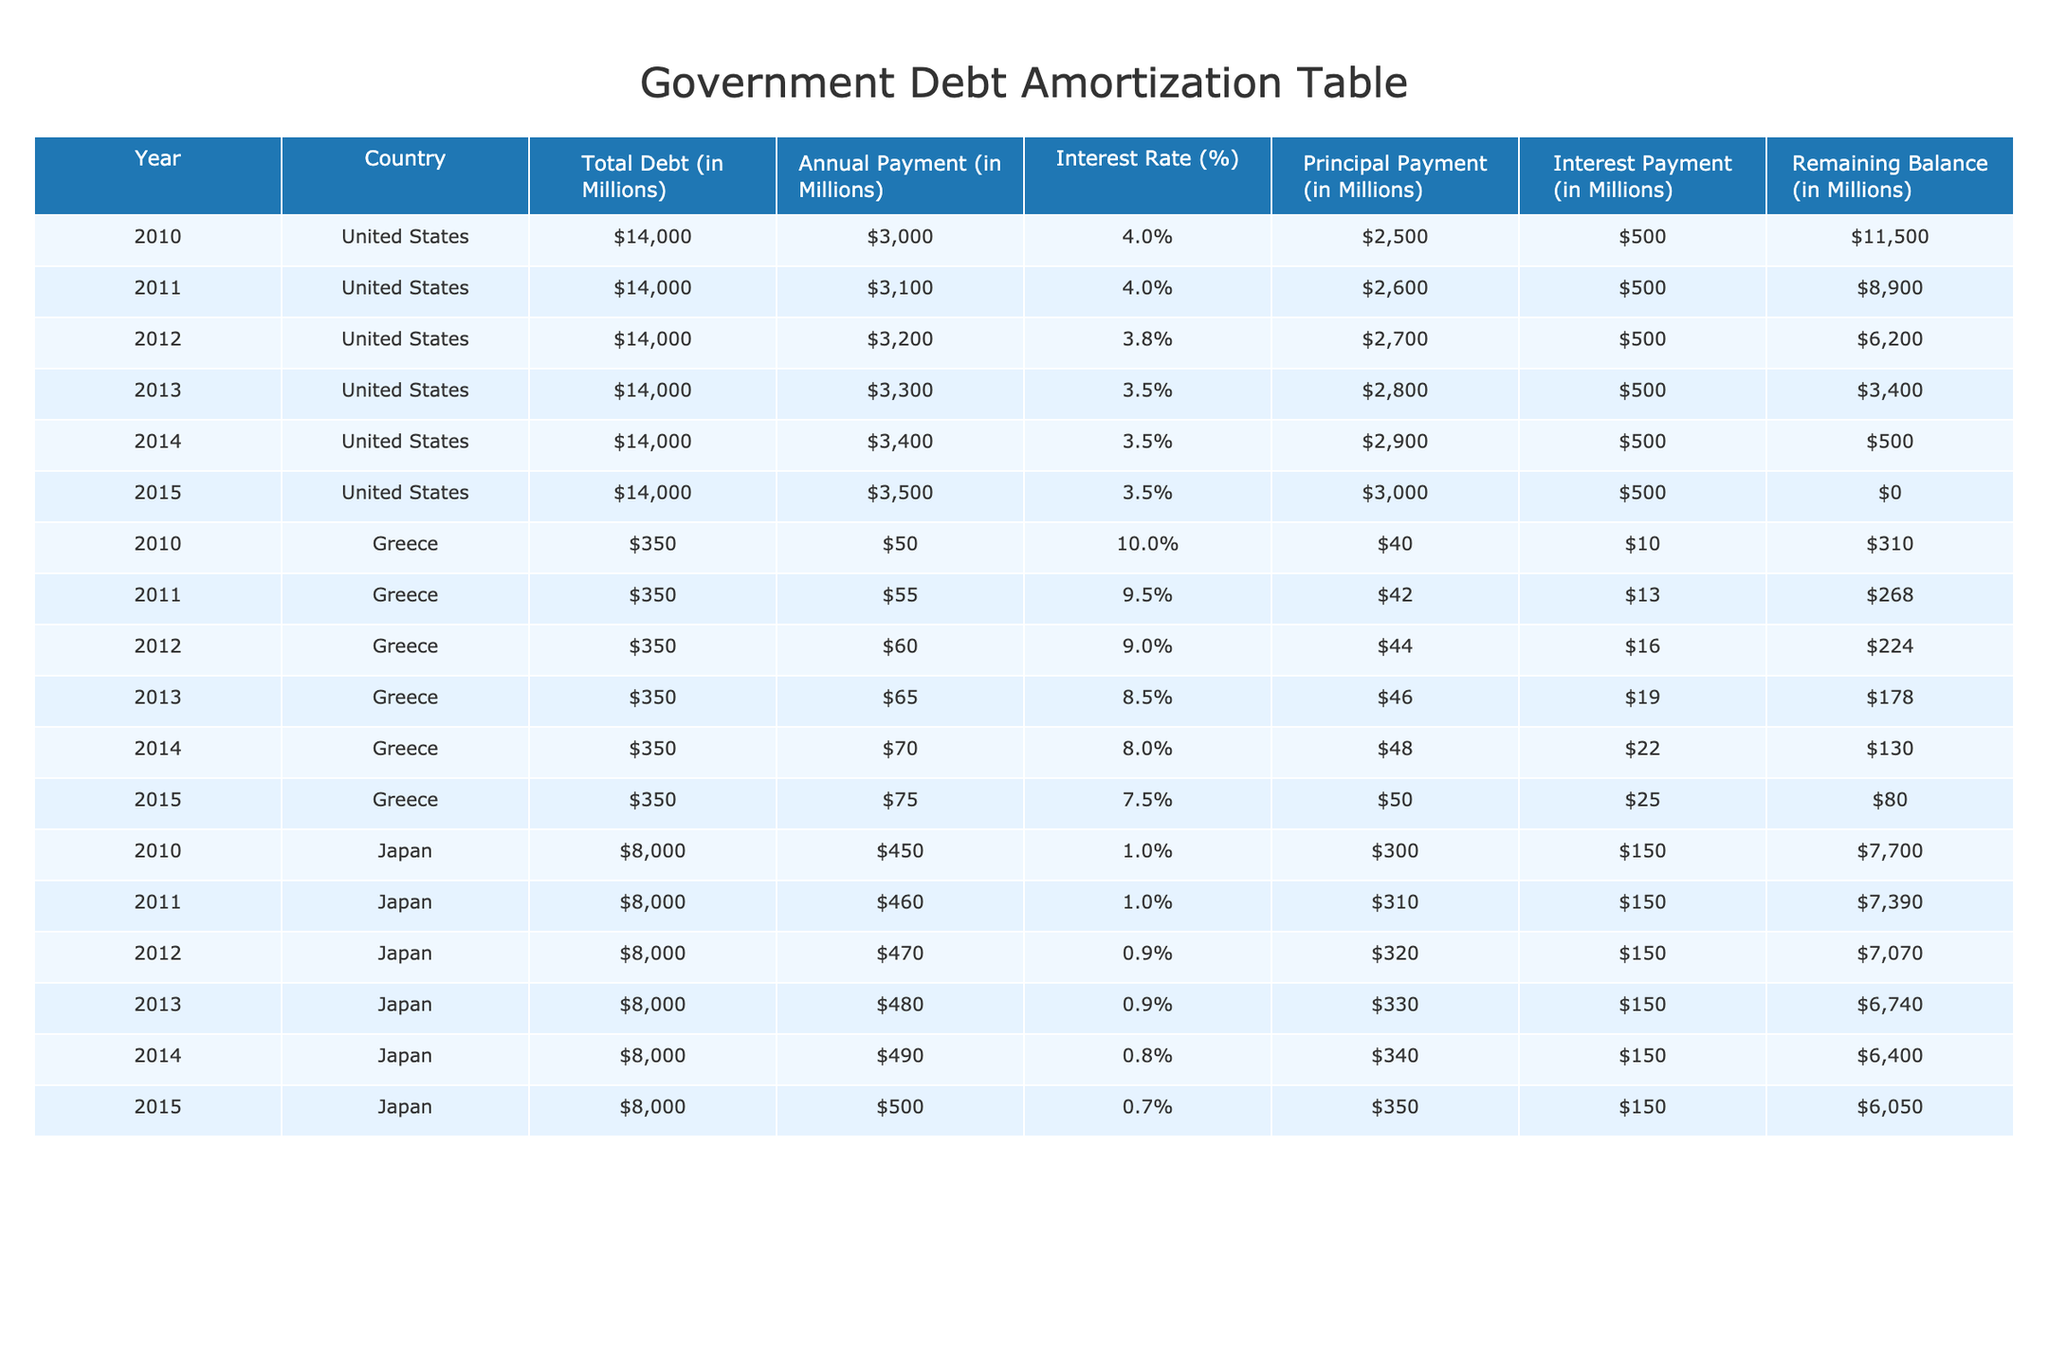What was the annual payment made by the United States in 2015? From the row corresponding to the United States in the year 2015, the annual payment listed is $3,500 million.
Answer: $3,500 million What is the remaining balance of Greece's debt in 2013? The table shows that, for Greece in 2013, the remaining balance is $178 million.
Answer: $178 million What was the total principal payment made by the United States from 2010 to 2015? Adding the principal payments for each year: $2,500 + $2,600 + $2,700 + $2,800 + $2,900 + $3,000 = $15,500 million.
Answer: $15,500 million Is the interest rate for Japan's debt higher than that of Greece in 2010? In 2010, Japan has an interest rate of 1.0%, whereas Greece has an interest rate of 10.0%. Since 1.0% is not higher than 10.0%, the answer is no.
Answer: No What percentage of the total debt did Greece pay off by 2015 compared to its total debt in 2010? Greece's total debt in 2010 was $350 million, and by 2015, the remaining balance was $80 million. The amount paid off is $350 - $80 = $270 million. The percentage paid off is (270/350) * 100 = 77.14%.
Answer: 77.14% 